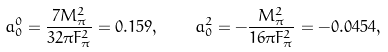<formula> <loc_0><loc_0><loc_500><loc_500>a _ { 0 } ^ { 0 } = \frac { 7 M _ { \pi } ^ { 2 } } { 3 2 \pi F _ { \pi } ^ { 2 } } = 0 . 1 5 9 , \quad a _ { 0 } ^ { 2 } = - \frac { M _ { \pi } ^ { 2 } } { 1 6 \pi F _ { \pi } ^ { 2 } } = - 0 . 0 4 5 4 ,</formula> 